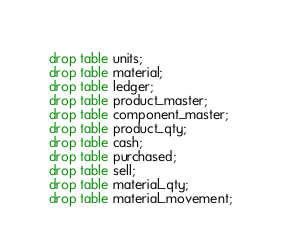Convert code to text. <code><loc_0><loc_0><loc_500><loc_500><_SQL_>drop table units;
drop table material;
drop table ledger;
drop table product_master;
drop table component_master;
drop table product_qty;
drop table cash;
drop table purchased;
drop table sell;
drop table material_qty;
drop table material_movement;</code> 